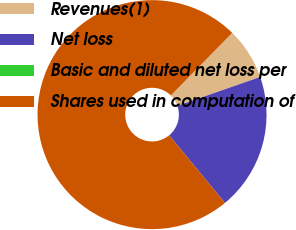Convert chart. <chart><loc_0><loc_0><loc_500><loc_500><pie_chart><fcel>Revenues(1)<fcel>Net loss<fcel>Basic and diluted net loss per<fcel>Shares used in computation of<nl><fcel>7.33%<fcel>19.34%<fcel>0.0%<fcel>73.33%<nl></chart> 